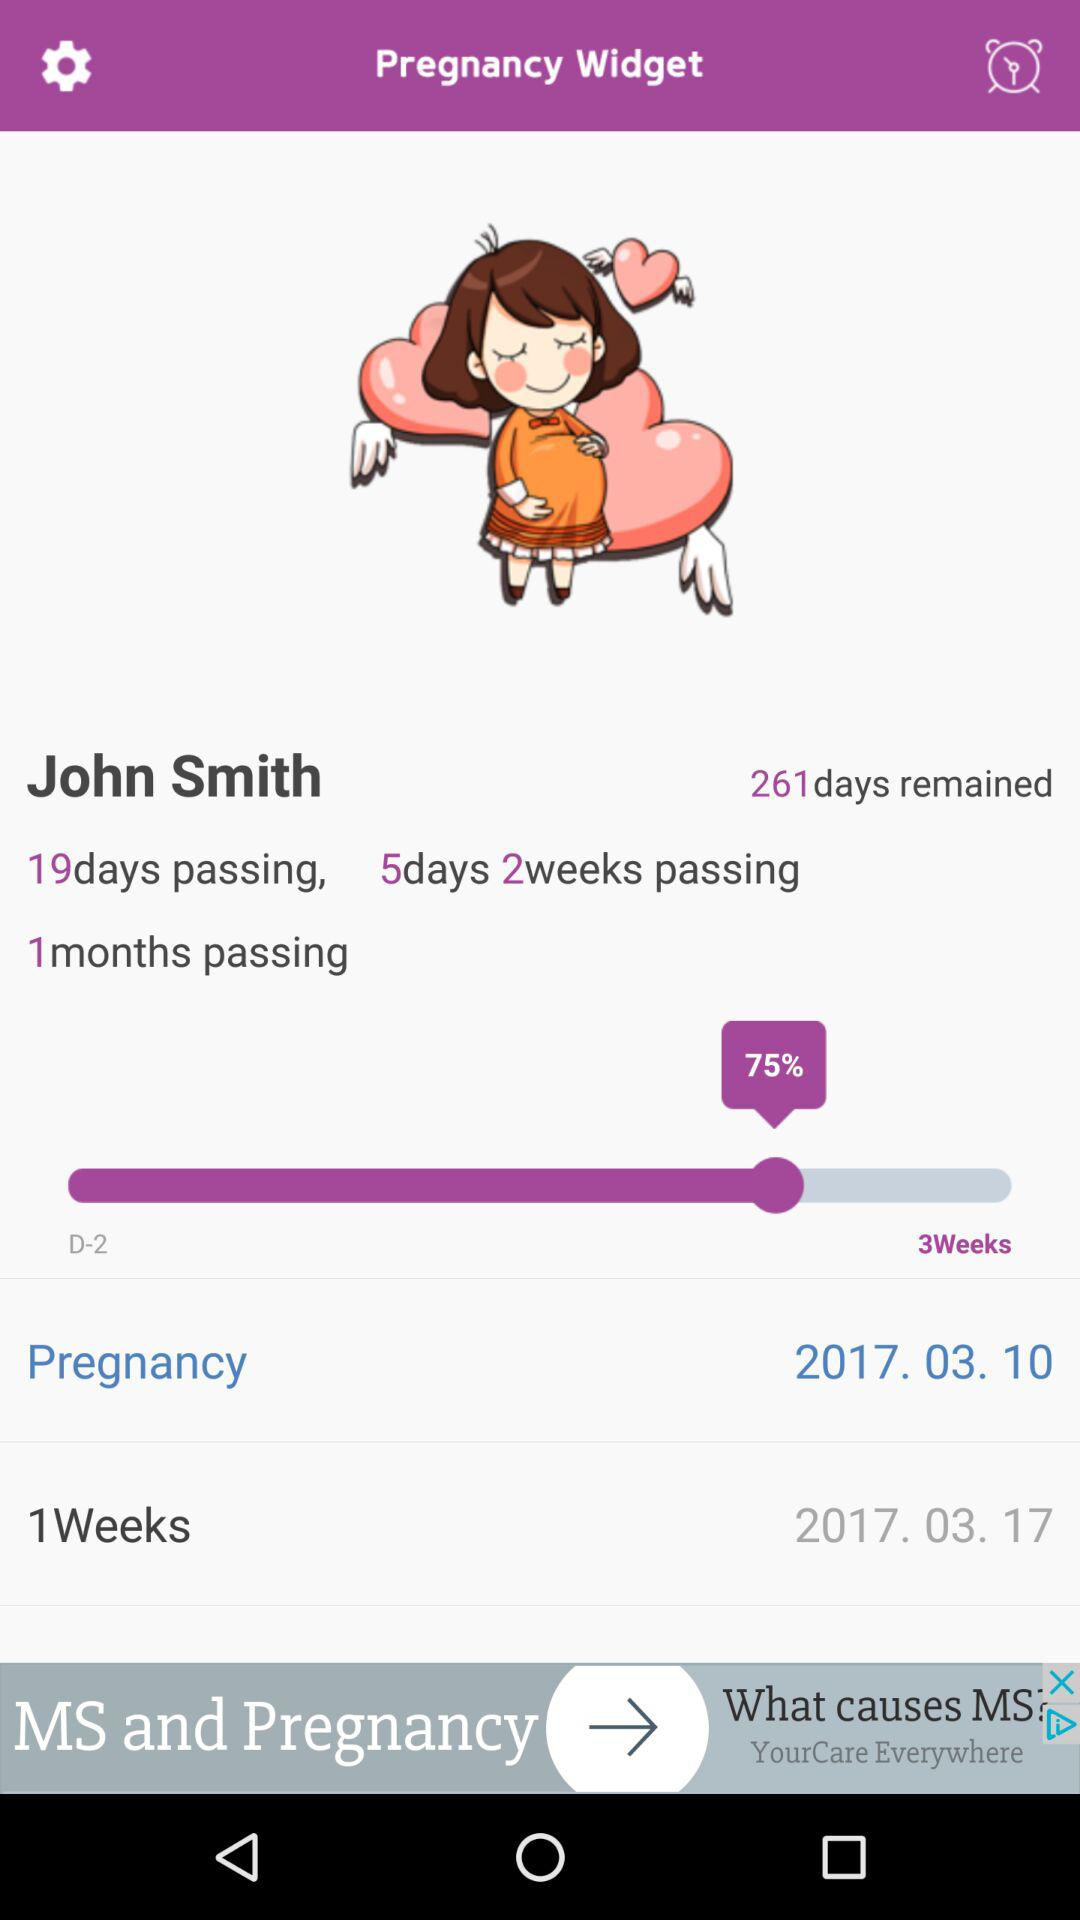What is the number of remaining days? The number of remaining days is 261. 